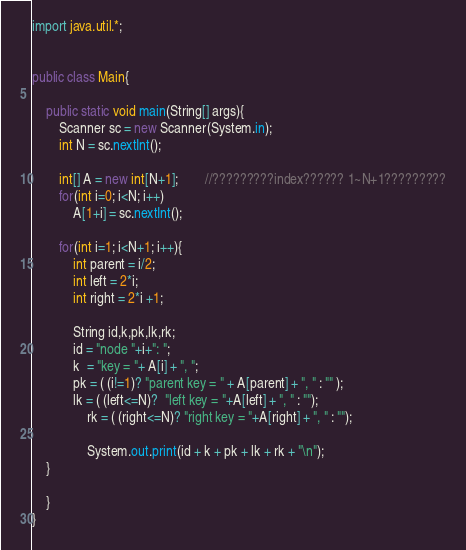Convert code to text. <code><loc_0><loc_0><loc_500><loc_500><_Java_>import java.util.*;


public class Main{

    public static void main(String[] args){
        Scanner sc = new Scanner(System.in);
        int N = sc.nextInt();
 
        int[] A = new int[N+1];		//?????????index?????? 1~N+1?????????
        for(int i=0; i<N; i++)		
            A[1+i] = sc.nextInt();	
 
 		for(int i=1; i<N+1; i++){	
	        int parent = i/2;
	        int left = 2*i;
	        int right = 2*i +1;

	        String id,k,pk,lk,rk;
	        id = "node "+i+": ";
	        k  = "key = "+ A[i] + ", ";
	        pk = ( (i!=1)? "parent key = " + A[parent] + ", " : "" );
	      	lk = ( (left<=N)?  "left key = "+A[left] + ", " : "");
                rk = ( (right<=N)? "right key = "+A[right] + ", " : "");
            
                System.out.print(id + k + pk + lk + rk + "\n");
	}
 
    }
}</code> 